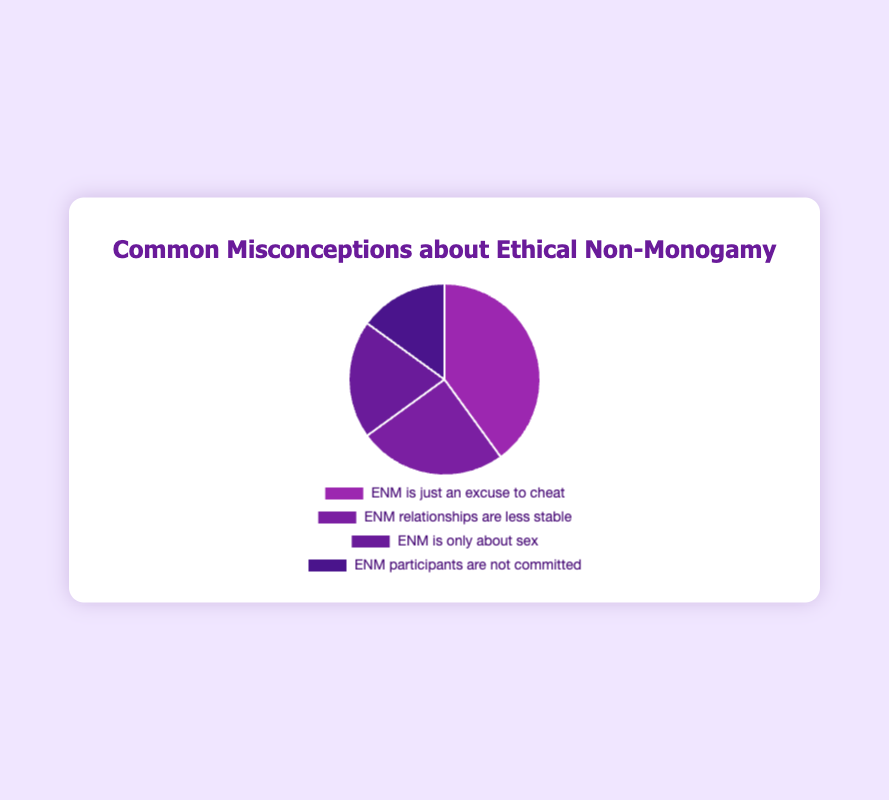What is the most common misconception about ethical non-monogamy (ENM)? The figure indicates the prevalence of each misconception. The misconception with the highest prevalence is the most common. "ENM is just an excuse to cheat" has the highest prevalence at 40%.
Answer: "ENM is just an excuse to cheat" Which misconception has the least prevalence? The misconception with the smallest percentage in the pie chart has the least prevalence. In this case, "ENM participants are not committed" has the smallest slice, with a prevalence of 15%.
Answer: "ENM participants are not committed" What is the combined prevalence of the misconceptions "ENM is only about sex" and "ENM participants are not committed"? The data shows "ENM is only about sex" at 20% and "ENM participants are not committed" at 15%. Adding these together gives 20% + 15% = 35%.
Answer: 35% Are "ENM is just an excuse to cheat" and "ENM relationships are less stable" more prevalent than the sum of the other two misconceptions? The prevalence of "ENM is just an excuse to cheat" is 40% and "ENM relationships are less stable" is 25%. Combined, they equal 40% + 25% = 65%. The sum of "ENM is only about sex" (20%) and "ENM participants are not committed" (15%) is 20% + 15% = 35%. Since 65% > 35%, the answer is yes.
Answer: Yes Which color represents the misconception "ENM relationships are less stable"? The pie chart uses different colors to represent each misconception. The segment for "ENM relationships are less stable" is marked in the second color. In the chart, it is a shade of purple (#7b1fa2).
Answer: Purple (#7b1fa2) How does the prevalence of "ENM is only about sex" compare to "ENM participants are not committed"? By comparing their slices, "ENM is only about sex" has a prevalence of 20%, while "ENM participants are not committed" has a prevalence of 15%. Therefore, "ENM is only about sex" is more prevalent.
Answer: "ENM is only about sex" is more prevalent What is the percentage difference between the most common and the least common misconceptions? The most common misconception is "ENM is just an excuse to cheat" at 40%. The least common is "ENM participants are not committed" at 15%. The difference is 40% - 15% = 25%.
Answer: 25% Rank the misconceptions from most prevalent to least prevalent. Observing the percentages: 1) "ENM is just an excuse to cheat" (40%), 2) "ENM relationships are less stable" (25%), 3) "ENM is only about sex" (20%), 4) "ENM participants are not committed" (15%).
Answer: 1) "ENM is just an excuse to cheat", 2) "ENM relationships are less stable", 3) "ENM is only about sex", 4) "ENM participants are not committed" Summing up the prevalences, what percentage of misconceptions belong to "ENM is just an excuse to cheat", "ENM relationships are less stable", and "ENM is only about sex"? Adding their respective prevalences gives 40% + 25% + 20% = 85%.
Answer: 85% 